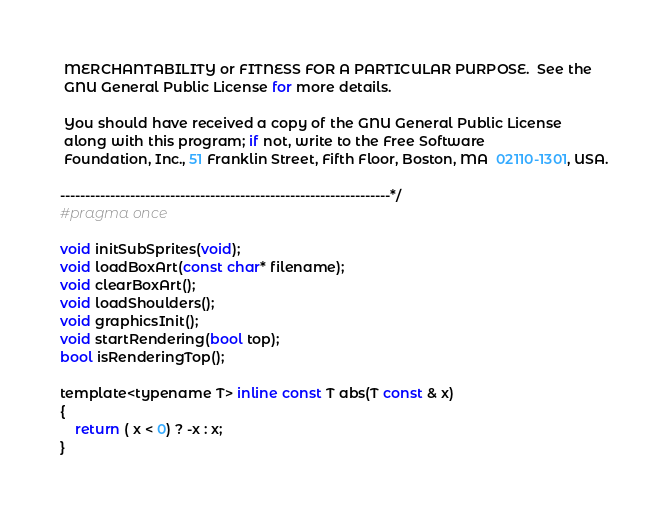Convert code to text. <code><loc_0><loc_0><loc_500><loc_500><_C_> MERCHANTABILITY or FITNESS FOR A PARTICULAR PURPOSE.  See the
 GNU General Public License for more details.

 You should have received a copy of the GNU General Public License
 along with this program; if not, write to the Free Software
 Foundation, Inc., 51 Franklin Street, Fifth Floor, Boston, MA  02110-1301, USA.

------------------------------------------------------------------*/
#pragma once

void initSubSprites(void);
void loadBoxArt(const char* filename);
void clearBoxArt();
void loadShoulders();
void graphicsInit();
void startRendering(bool top);
bool isRenderingTop();

template<typename T> inline const T abs(T const & x)
{
	return ( x < 0) ? -x : x;
}</code> 